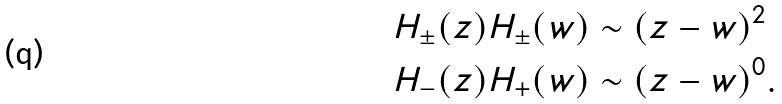Convert formula to latex. <formula><loc_0><loc_0><loc_500><loc_500>H _ { \pm } ( z ) H _ { \pm } ( w ) & \sim ( z - w ) ^ { 2 } \\ H _ { - } ( z ) H _ { + } ( w ) & \sim ( z - w ) ^ { 0 } .</formula> 